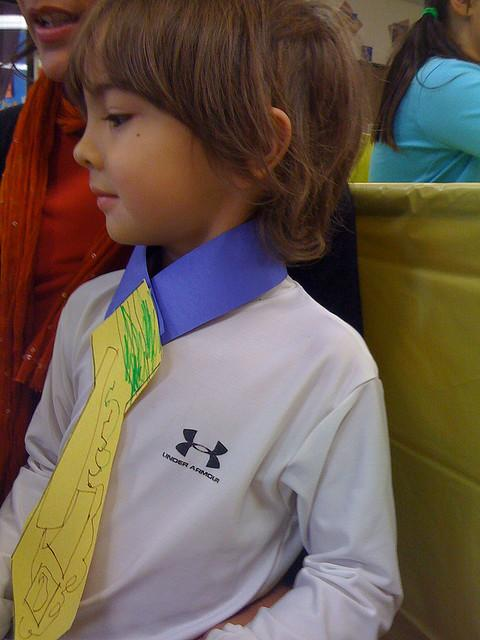What is the small child's tie made out of?

Choices:
A) plastic
B) paper
C) metal
D) cotton paper 